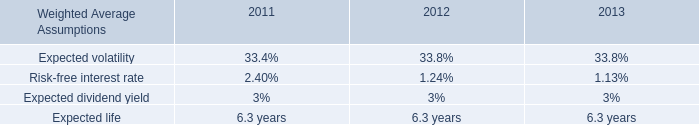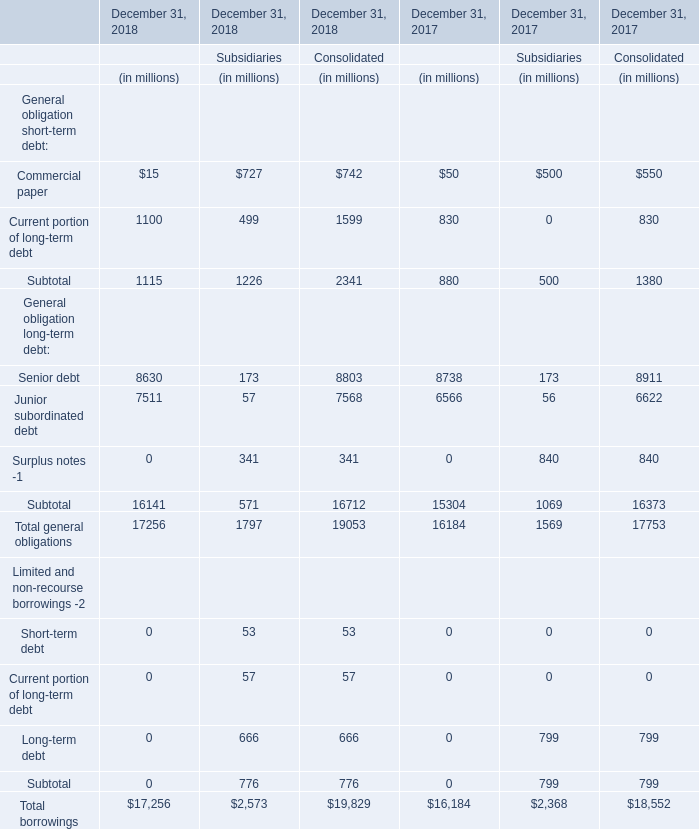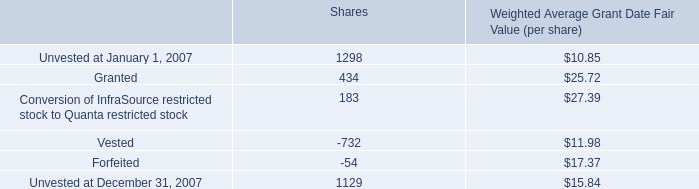What is the growing rate of Surplus notes -1 in the year with the least Commercial paper? 
Computations: ((((0 + 341) + 341) + ((0 + 840) + 840)) / ((0 + 840) + 840))
Answer: 1.40595. 